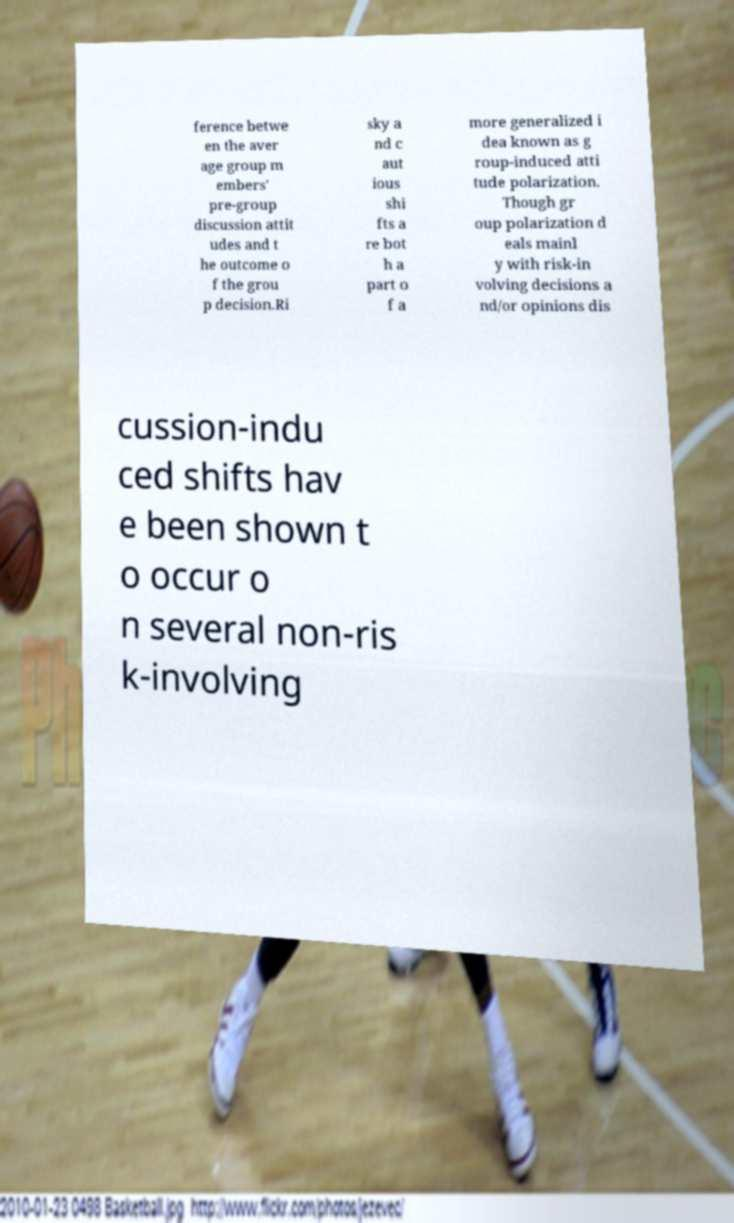There's text embedded in this image that I need extracted. Can you transcribe it verbatim? ference betwe en the aver age group m embers' pre-group discussion attit udes and t he outcome o f the grou p decision.Ri sky a nd c aut ious shi fts a re bot h a part o f a more generalized i dea known as g roup-induced atti tude polarization. Though gr oup polarization d eals mainl y with risk-in volving decisions a nd/or opinions dis cussion-indu ced shifts hav e been shown t o occur o n several non-ris k-involving 